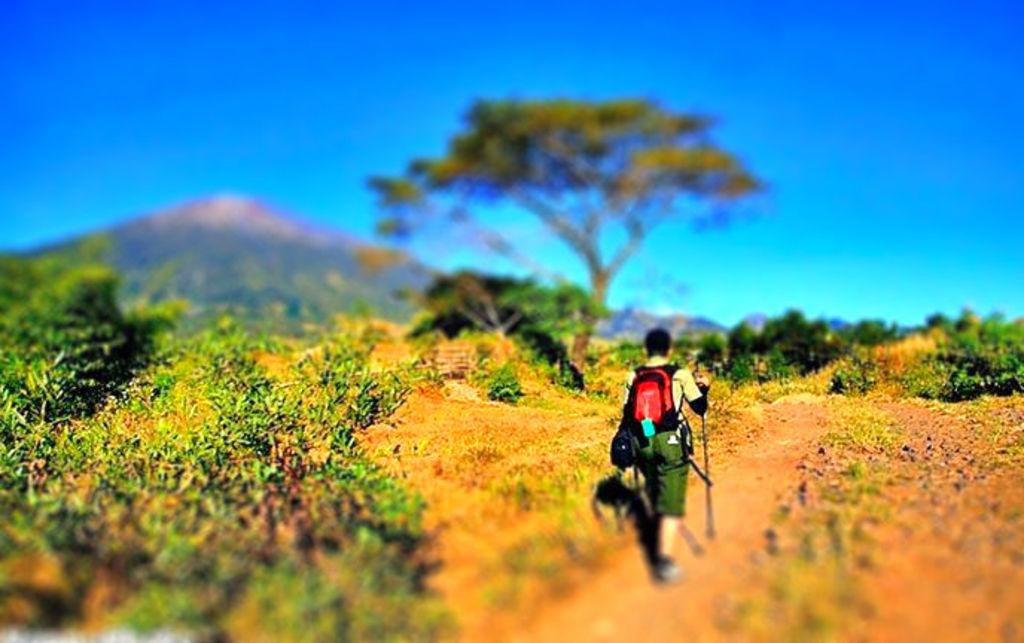Who is the main subject in the image? There is a man in the center of the image. What is the man doing in the image? The man is walking in the image. What is the man holding in the image? The man is holding a stick in the image. What is the man wearing in the image? The man is wearing a red bag in the image. What type of vegetation can be seen in the image? There are plants and trees in the image. What type of marble is visible in the image? There is no marble present in the image. How does the man's back look like in the image? The image does not provide a clear view of the man's back, so it cannot be described in detail. 